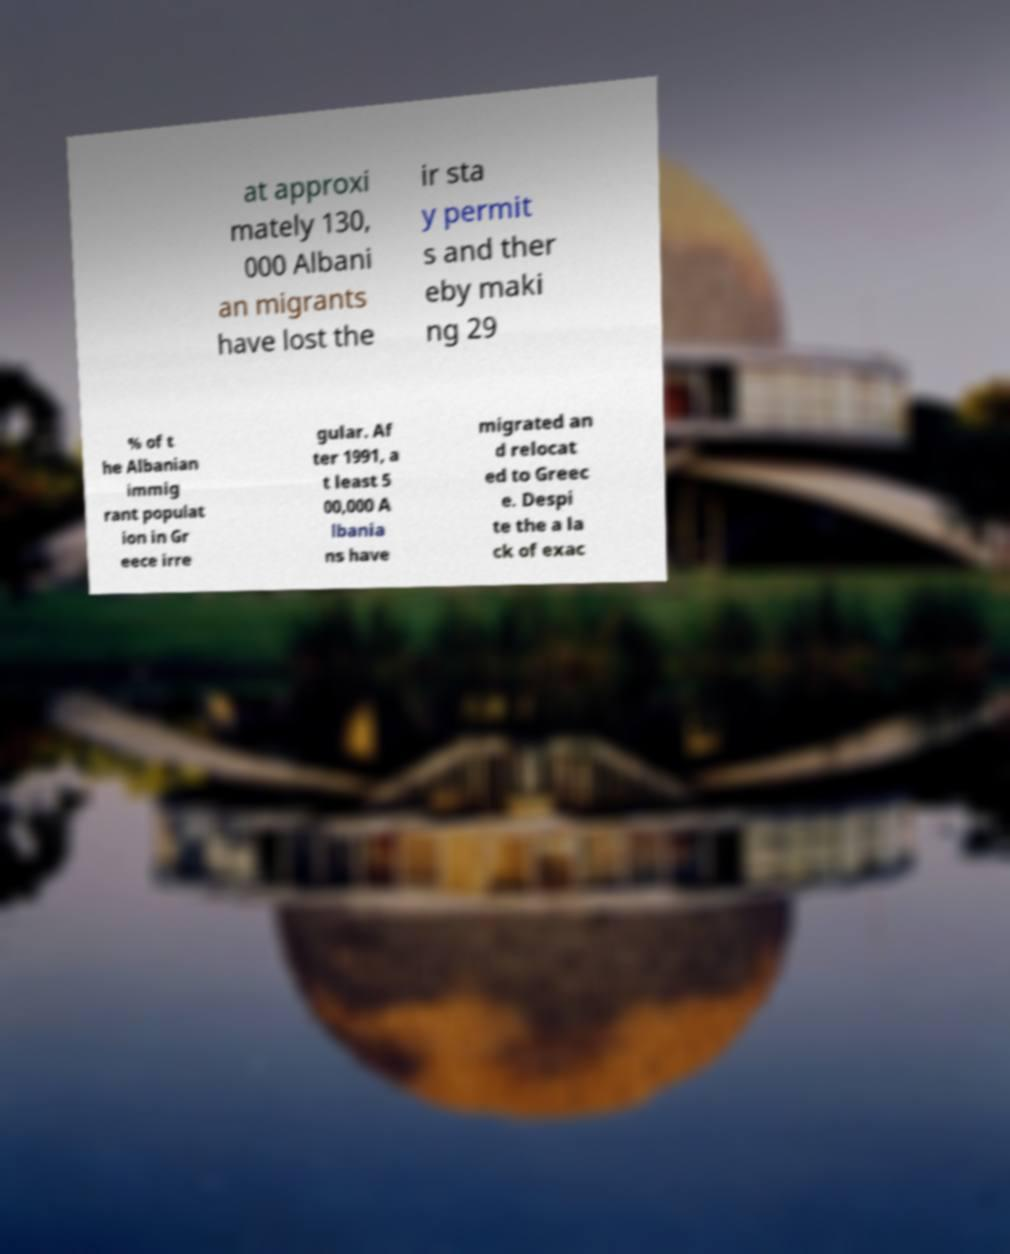Could you extract and type out the text from this image? at approxi mately 130, 000 Albani an migrants have lost the ir sta y permit s and ther eby maki ng 29 % of t he Albanian immig rant populat ion in Gr eece irre gular. Af ter 1991, a t least 5 00,000 A lbania ns have migrated an d relocat ed to Greec e. Despi te the a la ck of exac 